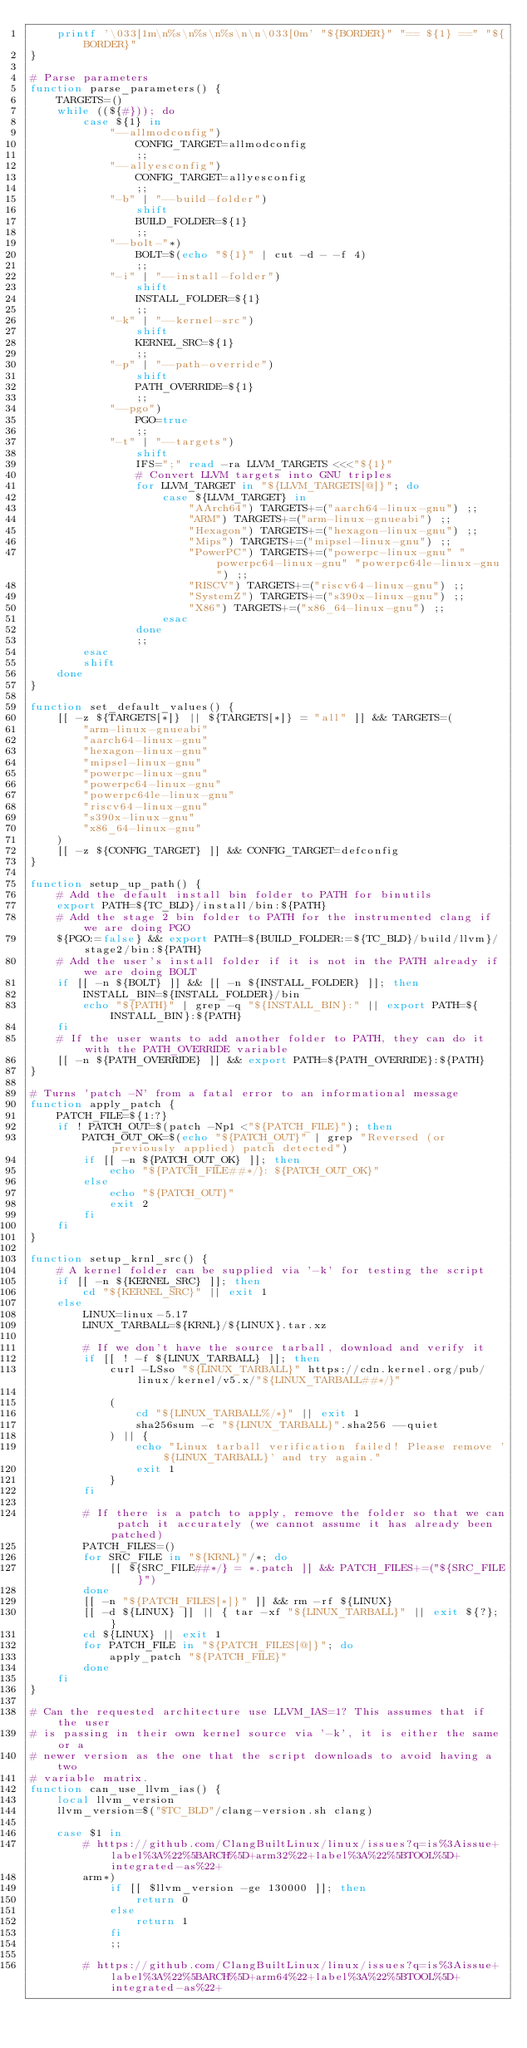Convert code to text. <code><loc_0><loc_0><loc_500><loc_500><_Bash_>    printf '\033[1m\n%s\n%s\n%s\n\n\033[0m' "${BORDER}" "== ${1} ==" "${BORDER}"
}

# Parse parameters
function parse_parameters() {
    TARGETS=()
    while ((${#})); do
        case ${1} in
            "--allmodconfig")
                CONFIG_TARGET=allmodconfig
                ;;
            "--allyesconfig")
                CONFIG_TARGET=allyesconfig
                ;;
            "-b" | "--build-folder")
                shift
                BUILD_FOLDER=${1}
                ;;
            "--bolt-"*)
                BOLT=$(echo "${1}" | cut -d - -f 4)
                ;;
            "-i" | "--install-folder")
                shift
                INSTALL_FOLDER=${1}
                ;;
            "-k" | "--kernel-src")
                shift
                KERNEL_SRC=${1}
                ;;
            "-p" | "--path-override")
                shift
                PATH_OVERRIDE=${1}
                ;;
            "--pgo")
                PGO=true
                ;;
            "-t" | "--targets")
                shift
                IFS=";" read -ra LLVM_TARGETS <<<"${1}"
                # Convert LLVM targets into GNU triples
                for LLVM_TARGET in "${LLVM_TARGETS[@]}"; do
                    case ${LLVM_TARGET} in
                        "AArch64") TARGETS+=("aarch64-linux-gnu") ;;
                        "ARM") TARGETS+=("arm-linux-gnueabi") ;;
                        "Hexagon") TARGETS+=("hexagon-linux-gnu") ;;
                        "Mips") TARGETS+=("mipsel-linux-gnu") ;;
                        "PowerPC") TARGETS+=("powerpc-linux-gnu" "powerpc64-linux-gnu" "powerpc64le-linux-gnu") ;;
                        "RISCV") TARGETS+=("riscv64-linux-gnu") ;;
                        "SystemZ") TARGETS+=("s390x-linux-gnu") ;;
                        "X86") TARGETS+=("x86_64-linux-gnu") ;;
                    esac
                done
                ;;
        esac
        shift
    done
}

function set_default_values() {
    [[ -z ${TARGETS[*]} || ${TARGETS[*]} = "all" ]] && TARGETS=(
        "arm-linux-gnueabi"
        "aarch64-linux-gnu"
        "hexagon-linux-gnu"
        "mipsel-linux-gnu"
        "powerpc-linux-gnu"
        "powerpc64-linux-gnu"
        "powerpc64le-linux-gnu"
        "riscv64-linux-gnu"
        "s390x-linux-gnu"
        "x86_64-linux-gnu"
    )
    [[ -z ${CONFIG_TARGET} ]] && CONFIG_TARGET=defconfig
}

function setup_up_path() {
    # Add the default install bin folder to PATH for binutils
    export PATH=${TC_BLD}/install/bin:${PATH}
    # Add the stage 2 bin folder to PATH for the instrumented clang if we are doing PGO
    ${PGO:=false} && export PATH=${BUILD_FOLDER:=${TC_BLD}/build/llvm}/stage2/bin:${PATH}
    # Add the user's install folder if it is not in the PATH already if we are doing BOLT
    if [[ -n ${BOLT} ]] && [[ -n ${INSTALL_FOLDER} ]]; then
        INSTALL_BIN=${INSTALL_FOLDER}/bin
        echo "${PATH}" | grep -q "${INSTALL_BIN}:" || export PATH=${INSTALL_BIN}:${PATH}
    fi
    # If the user wants to add another folder to PATH, they can do it with the PATH_OVERRIDE variable
    [[ -n ${PATH_OVERRIDE} ]] && export PATH=${PATH_OVERRIDE}:${PATH}
}

# Turns 'patch -N' from a fatal error to an informational message
function apply_patch {
    PATCH_FILE=${1:?}
    if ! PATCH_OUT=$(patch -Np1 <"${PATCH_FILE}"); then
        PATCH_OUT_OK=$(echo "${PATCH_OUT}" | grep "Reversed (or previously applied) patch detected")
        if [[ -n ${PATCH_OUT_OK} ]]; then
            echo "${PATCH_FILE##*/}: ${PATCH_OUT_OK}"
        else
            echo "${PATCH_OUT}"
            exit 2
        fi
    fi
}

function setup_krnl_src() {
    # A kernel folder can be supplied via '-k' for testing the script
    if [[ -n ${KERNEL_SRC} ]]; then
        cd "${KERNEL_SRC}" || exit 1
    else
        LINUX=linux-5.17
        LINUX_TARBALL=${KRNL}/${LINUX}.tar.xz

        # If we don't have the source tarball, download and verify it
        if [[ ! -f ${LINUX_TARBALL} ]]; then
            curl -LSso "${LINUX_TARBALL}" https://cdn.kernel.org/pub/linux/kernel/v5.x/"${LINUX_TARBALL##*/}"

            (
                cd "${LINUX_TARBALL%/*}" || exit 1
                sha256sum -c "${LINUX_TARBALL}".sha256 --quiet
            ) || {
                echo "Linux tarball verification failed! Please remove '${LINUX_TARBALL}' and try again."
                exit 1
            }
        fi

        # If there is a patch to apply, remove the folder so that we can patch it accurately (we cannot assume it has already been patched)
        PATCH_FILES=()
        for SRC_FILE in "${KRNL}"/*; do
            [[ ${SRC_FILE##*/} = *.patch ]] && PATCH_FILES+=("${SRC_FILE}")
        done
        [[ -n "${PATCH_FILES[*]}" ]] && rm -rf ${LINUX}
        [[ -d ${LINUX} ]] || { tar -xf "${LINUX_TARBALL}" || exit ${?}; }
        cd ${LINUX} || exit 1
        for PATCH_FILE in "${PATCH_FILES[@]}"; do
            apply_patch "${PATCH_FILE}"
        done
    fi
}

# Can the requested architecture use LLVM_IAS=1? This assumes that if the user
# is passing in their own kernel source via '-k', it is either the same or a
# newer version as the one that the script downloads to avoid having a two
# variable matrix.
function can_use_llvm_ias() {
    local llvm_version
    llvm_version=$("$TC_BLD"/clang-version.sh clang)

    case $1 in
        # https://github.com/ClangBuiltLinux/linux/issues?q=is%3Aissue+label%3A%22%5BARCH%5D+arm32%22+label%3A%22%5BTOOL%5D+integrated-as%22+
        arm*)
            if [[ $llvm_version -ge 130000 ]]; then
                return 0
            else
                return 1
            fi
            ;;

        # https://github.com/ClangBuiltLinux/linux/issues?q=is%3Aissue+label%3A%22%5BARCH%5D+arm64%22+label%3A%22%5BTOOL%5D+integrated-as%22+</code> 